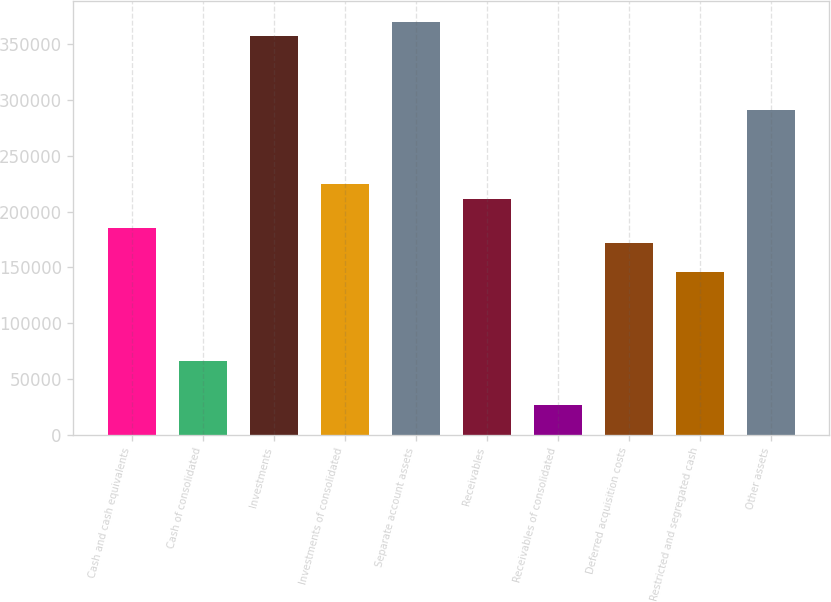Convert chart. <chart><loc_0><loc_0><loc_500><loc_500><bar_chart><fcel>Cash and cash equivalents<fcel>Cash of consolidated<fcel>Investments<fcel>Investments of consolidated<fcel>Separate account assets<fcel>Receivables<fcel>Receivables of consolidated<fcel>Deferred acquisition costs<fcel>Restricted and segregated cash<fcel>Other assets<nl><fcel>185229<fcel>66155<fcel>357224<fcel>224920<fcel>370454<fcel>211689<fcel>26463.8<fcel>171998<fcel>145537<fcel>291072<nl></chart> 